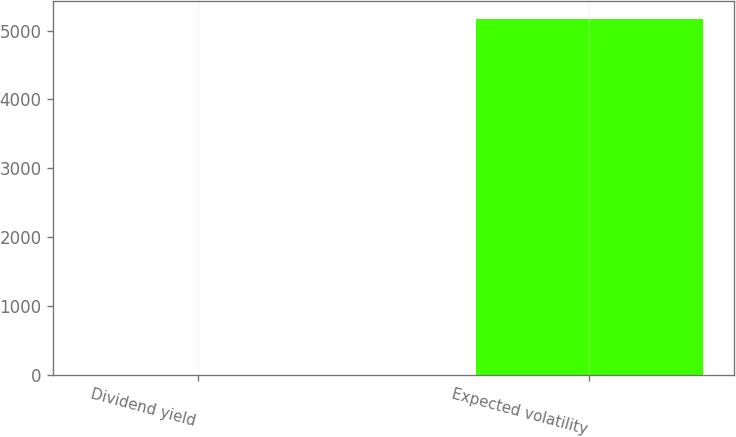<chart> <loc_0><loc_0><loc_500><loc_500><bar_chart><fcel>Dividend yield<fcel>Expected volatility<nl><fcel>3.23<fcel>5165<nl></chart> 